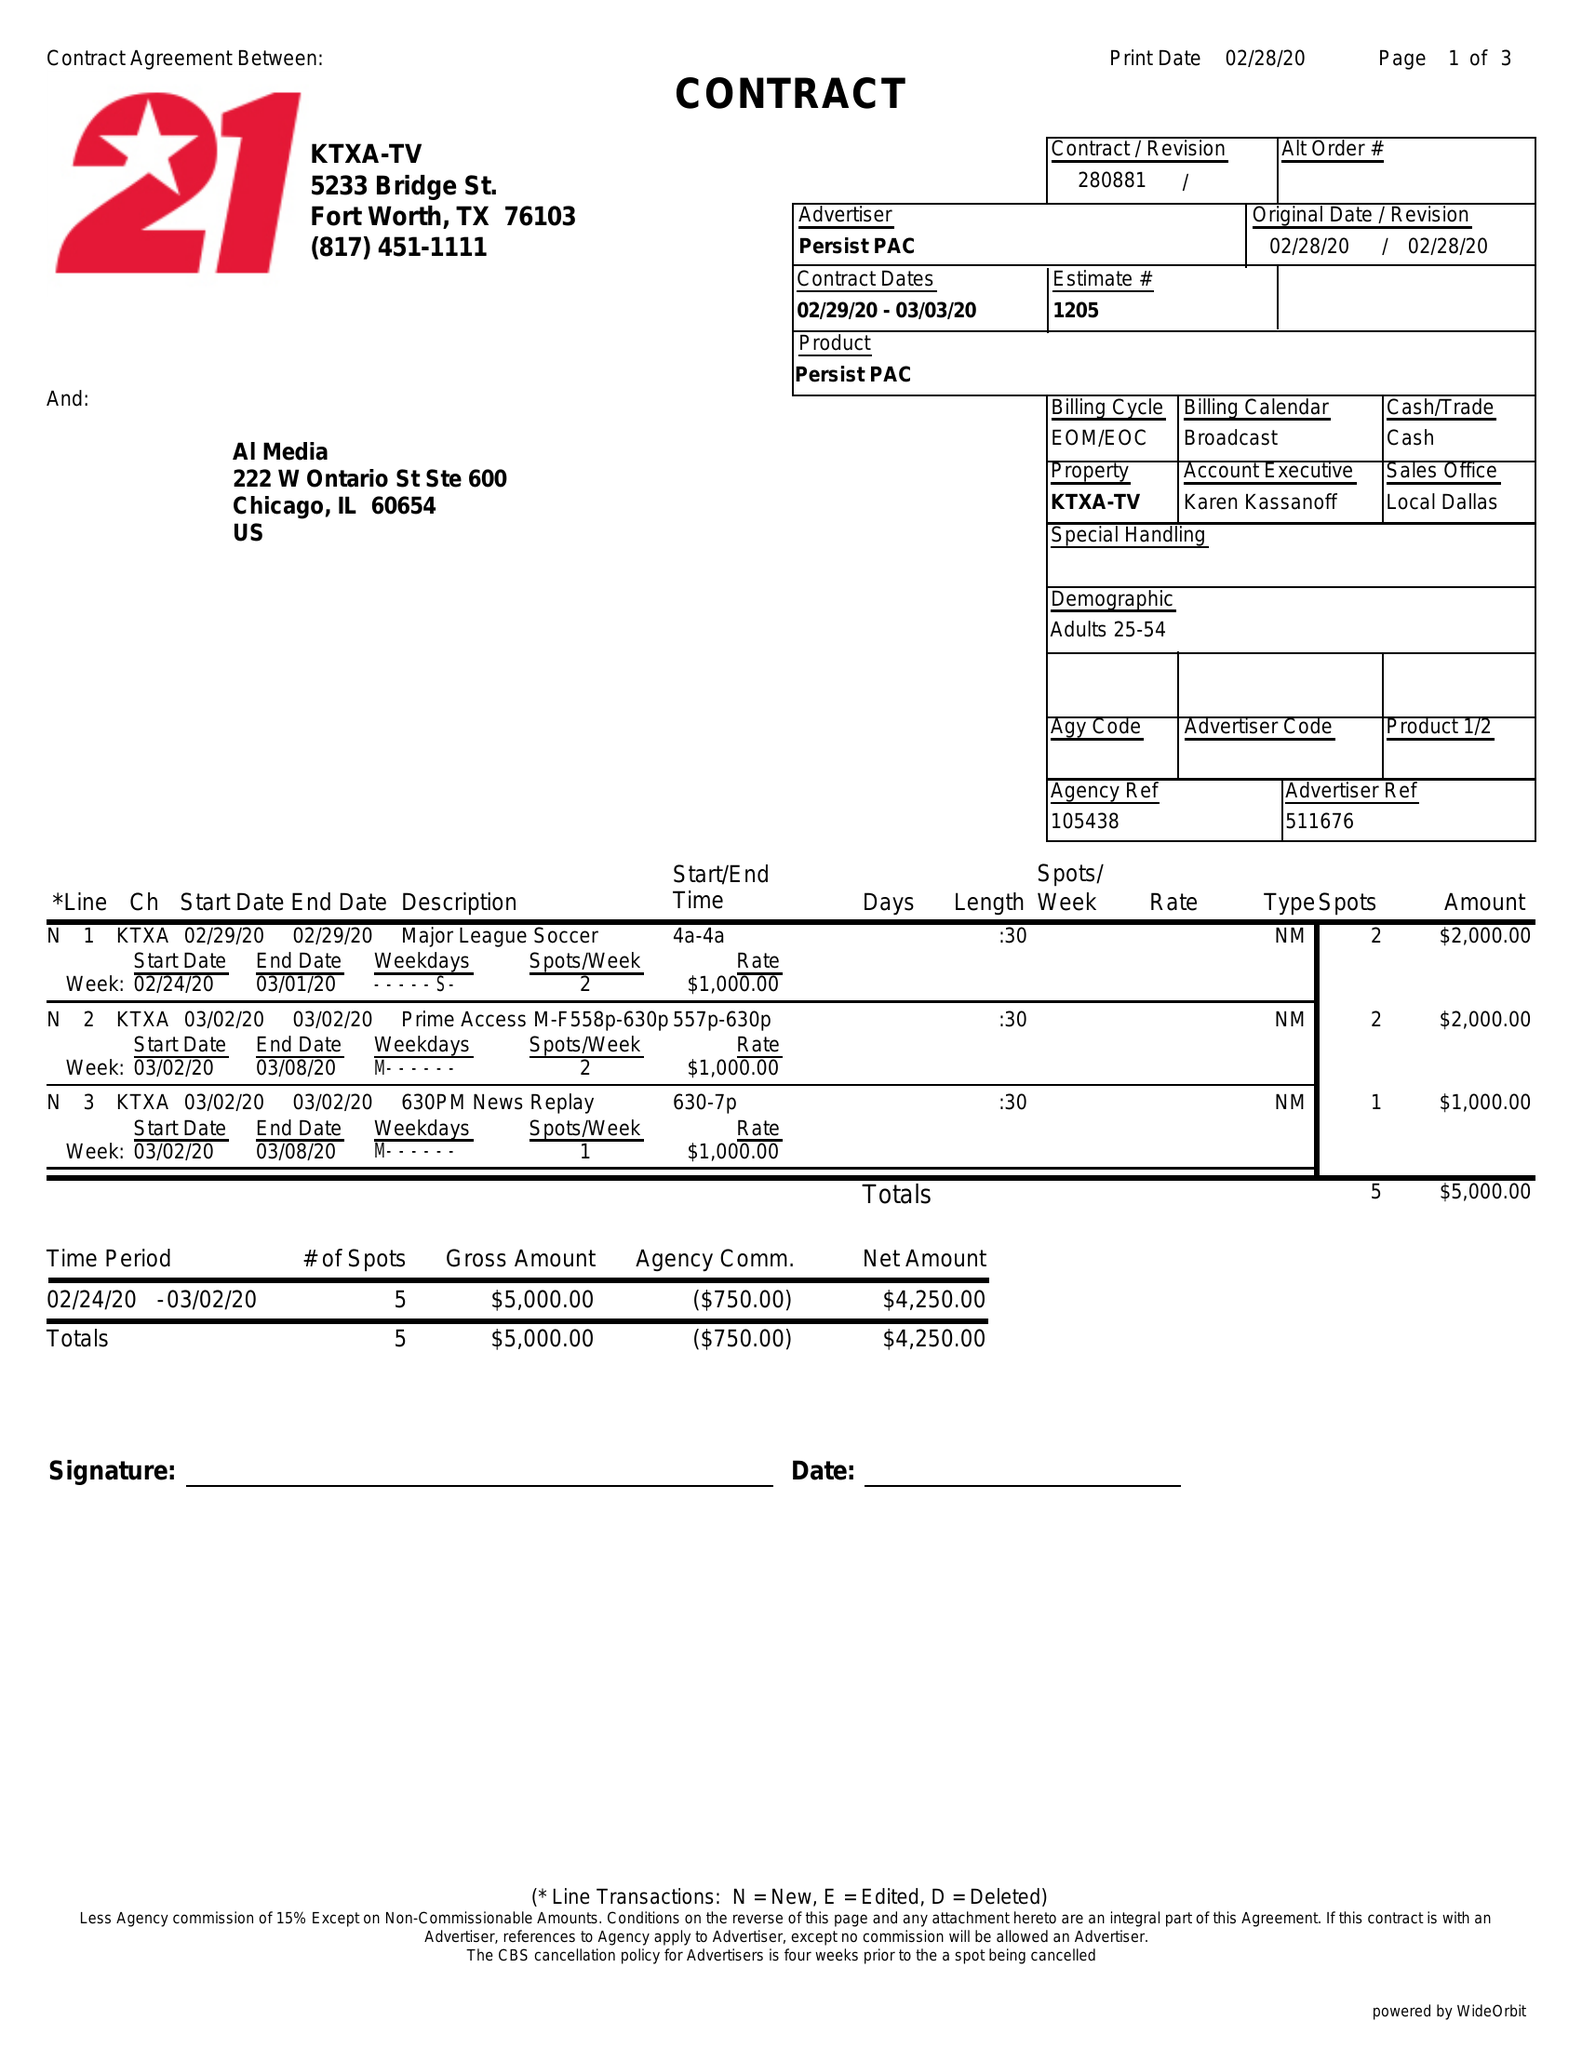What is the value for the contract_num?
Answer the question using a single word or phrase. 280881 